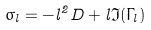<formula> <loc_0><loc_0><loc_500><loc_500>\sigma _ { l } = - l ^ { 2 } D + l \Im ( \Gamma _ { l } )</formula> 